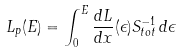<formula> <loc_0><loc_0><loc_500><loc_500>L _ { p } ( E ) = \int ^ { E } _ { 0 } \frac { d L } { d x } ( \epsilon ) S ^ { - 1 } _ { t o t } \, d \epsilon</formula> 